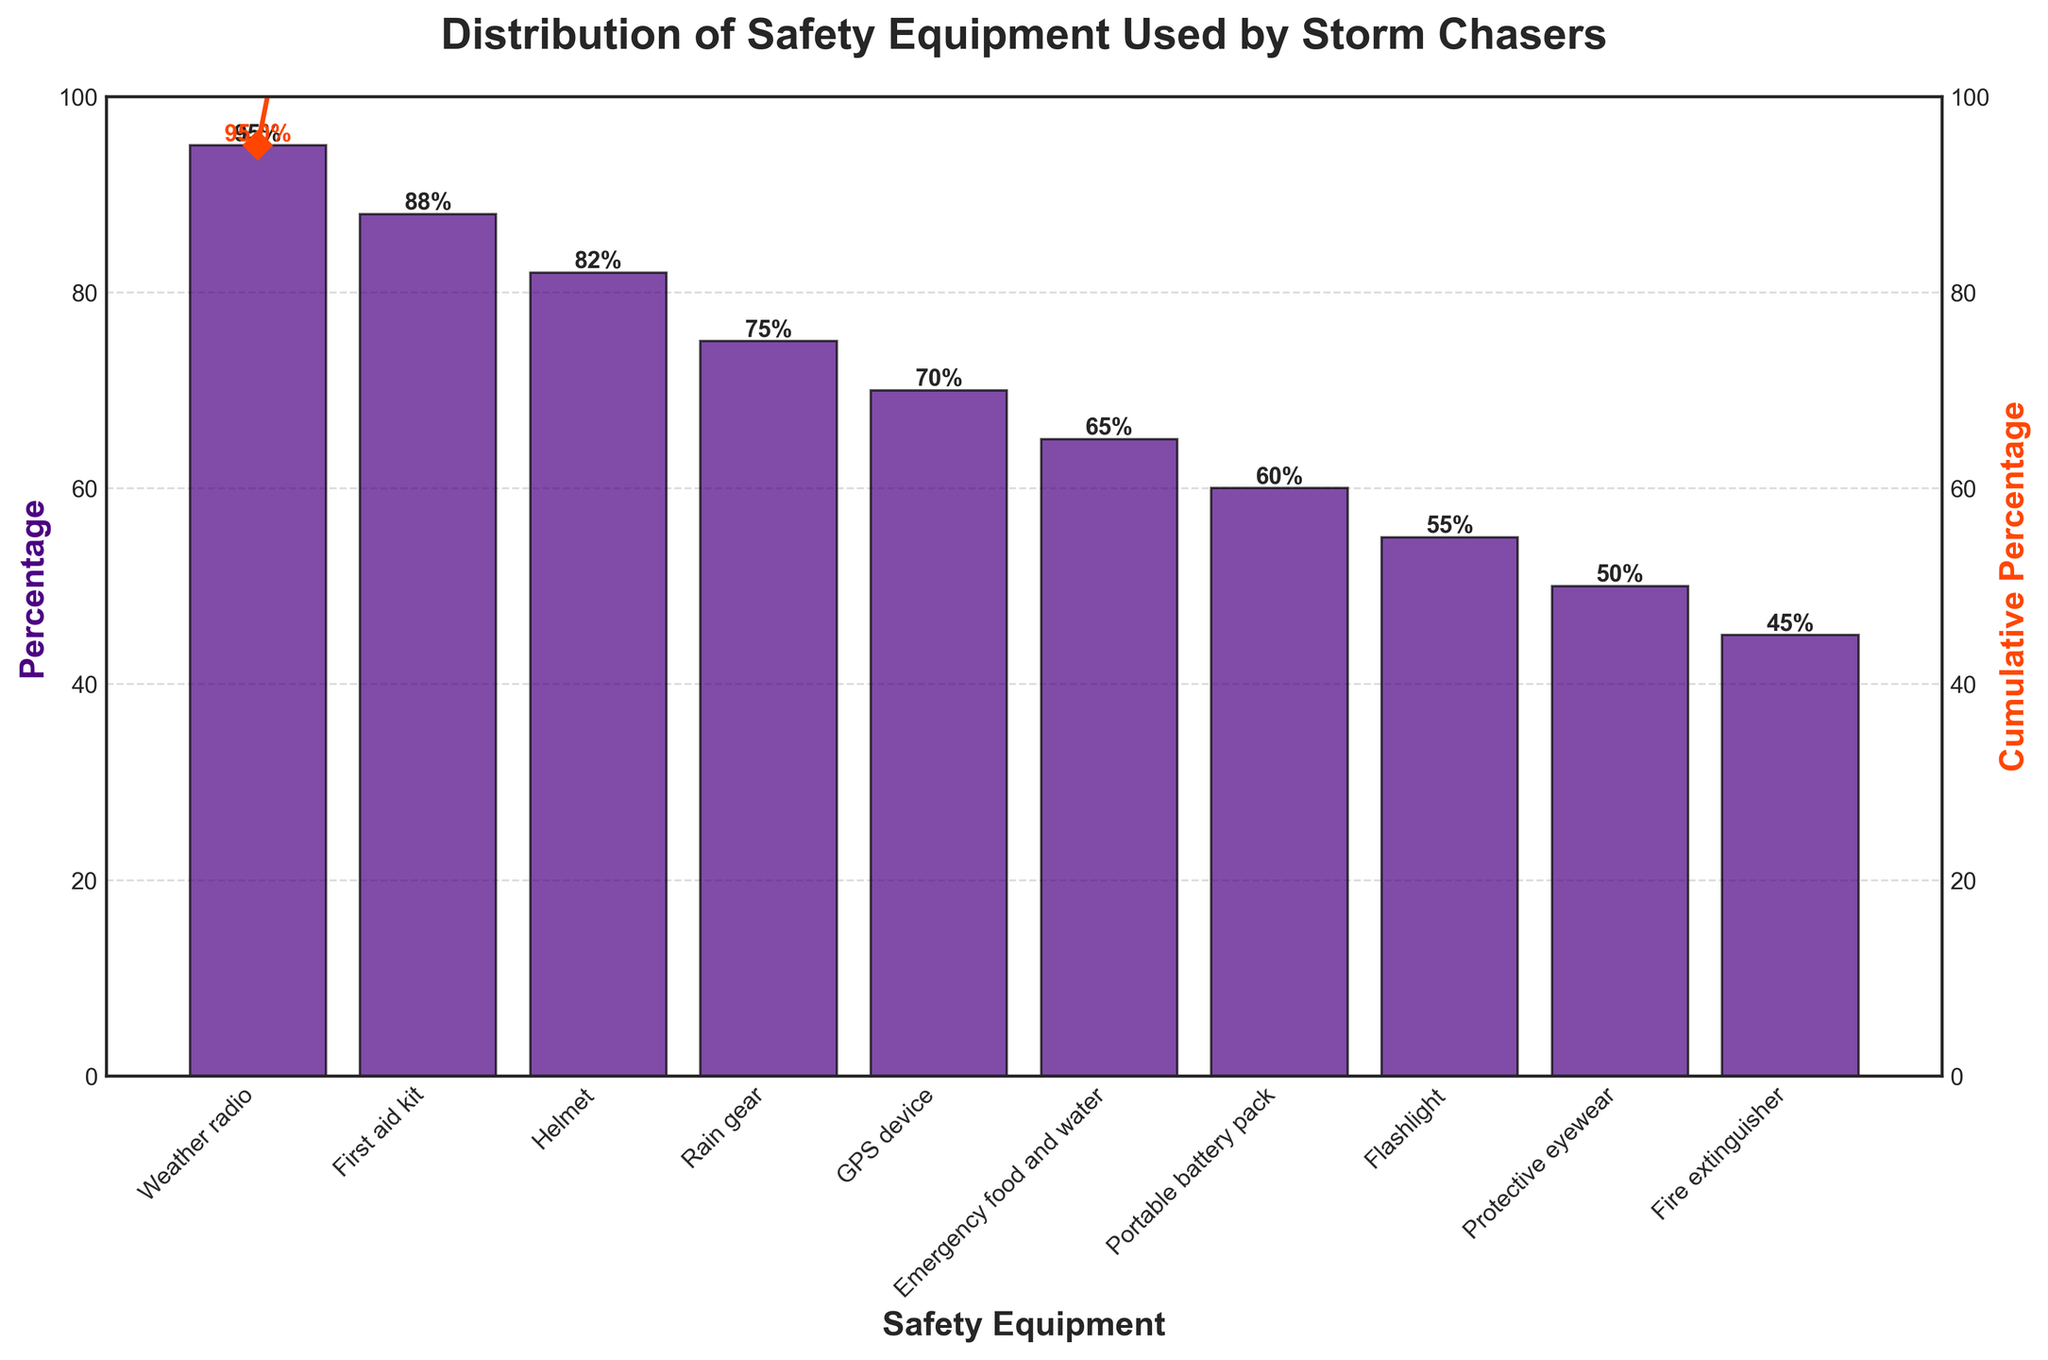What is the title of the figure? The title is at the top of the figure, displaying the main topic or focus.
Answer: Distribution of Safety Equipment Used by Storm Chasers Which safety equipment has the highest percentage? Look at the top bar in the bar chart to find the tallest one, as it represents the highest percentage.
Answer: Weather radio How many safety equipment items have a percentage greater than 80%? Identify and count the bars that exceed the 80% mark along the y-axis.
Answer: 3 What is the cumulative percentage for the first four safety equipment items? Find the cumulative percentage values for the first four items on the secondary y-axis or red line and add them up: 95% + 88% + 82% + 75% = 340%.
Answer: 340% Compare the percentage of storm chasers using a helmet and a GPS device. Which is higher? Look at the respective bars for helmet and GPS device to compare their heights.
Answer: Helmet By how much is the percentage of emergency food and water higher than that of protective eyewear? Subtract the percentage of protective eyewear from that of emergency food and water: 65% - 50% = 15%.
Answer: 15% What percentage of storm chasers use portable battery packs? Locate the bar corresponding to portable battery packs and read the percentage value near the top of the bar.
Answer: 60% Is there any safety equipment with a cumulative percentage exactly at 100%? Check the cumulative percentage values plotted as points along the red line to see if any exactly equal 100%.
Answer: No How many safety equipment items have a percentage less than 60%? Count the bars that are below the 60% mark on the y-axis.
Answer: 4 What is the cumulative percentage after considering the first aid kit? Look at the cumulative percentage value corresponding to the first aid kit's position on the red line.
Answer: 183% 